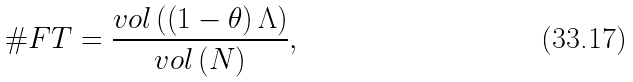Convert formula to latex. <formula><loc_0><loc_0><loc_500><loc_500>\# F T = \frac { v o l \left ( \left ( 1 - \theta \right ) \Lambda \right ) } { v o l \left ( N \right ) } ,</formula> 